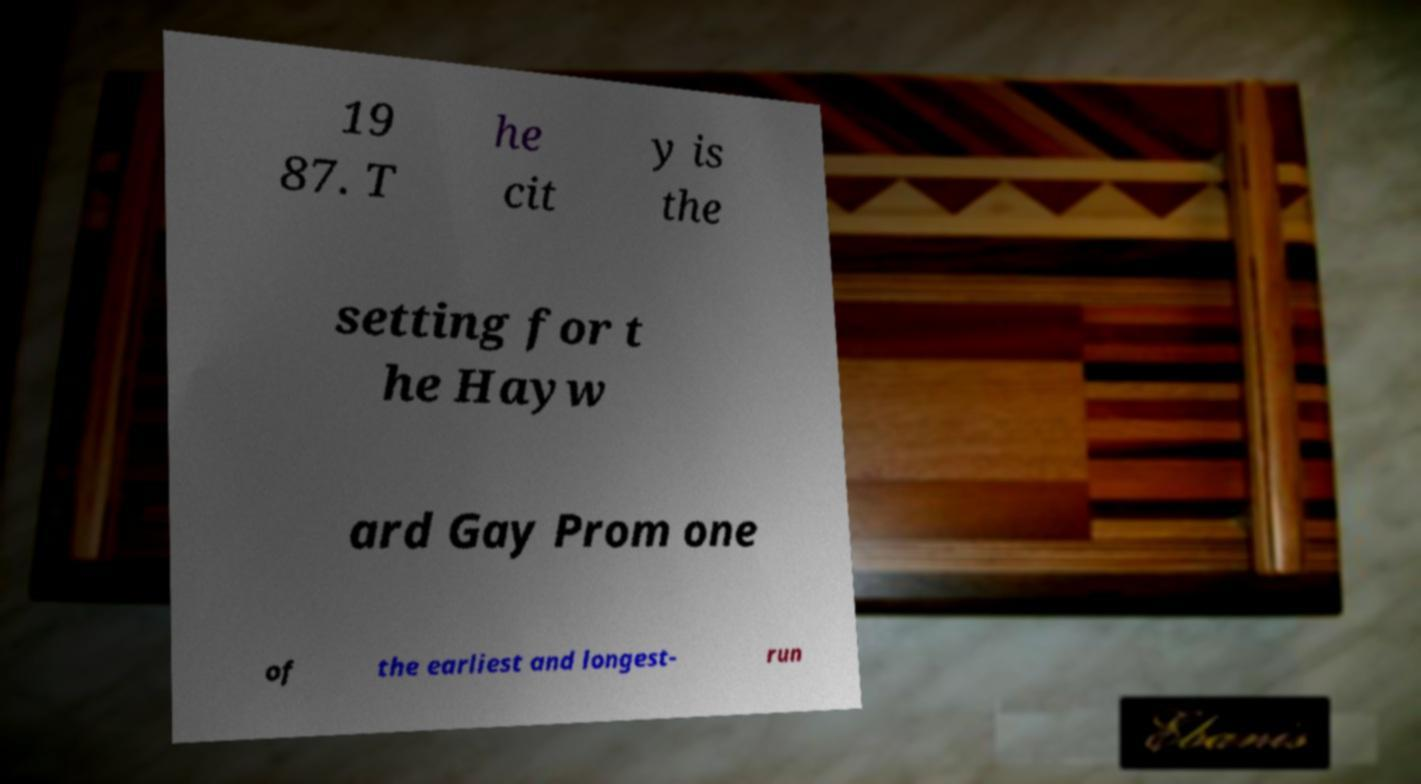Can you read and provide the text displayed in the image?This photo seems to have some interesting text. Can you extract and type it out for me? 19 87. T he cit y is the setting for t he Hayw ard Gay Prom one of the earliest and longest- run 